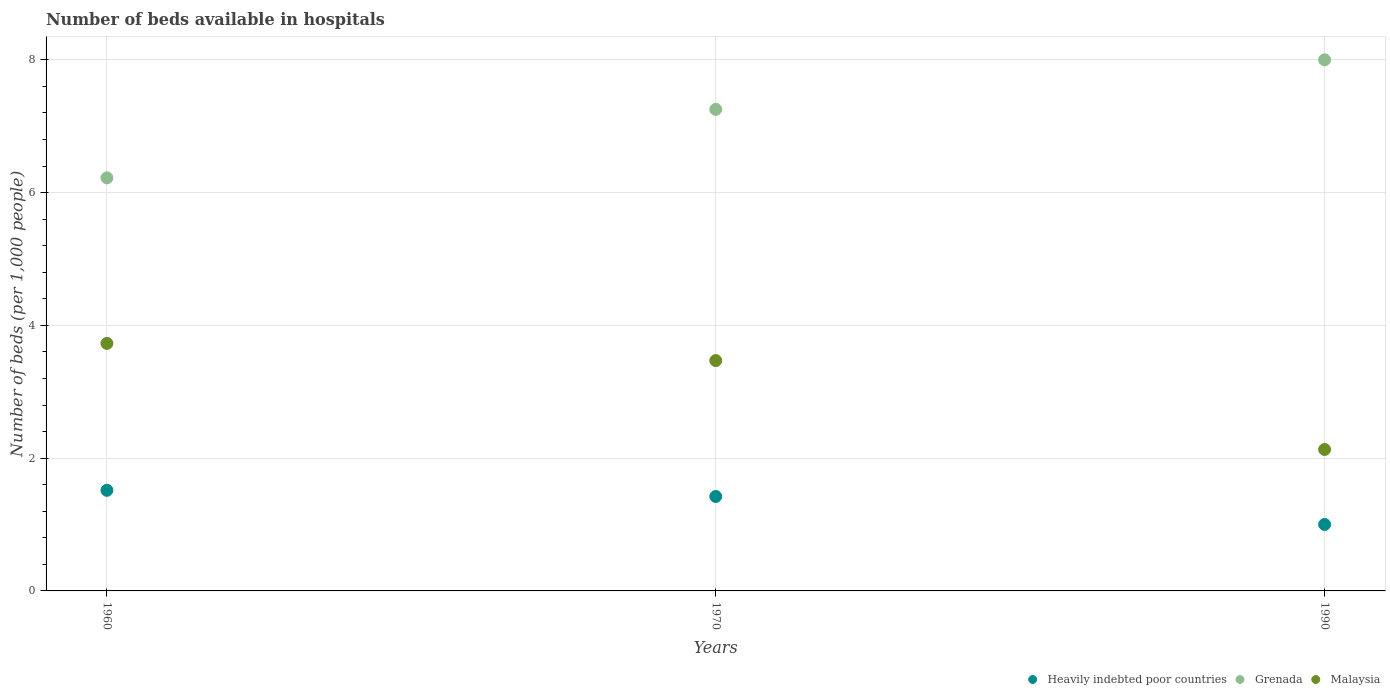How many different coloured dotlines are there?
Offer a terse response. 3. Is the number of dotlines equal to the number of legend labels?
Your response must be concise. Yes. What is the number of beds in the hospiatls of in Heavily indebted poor countries in 1960?
Make the answer very short. 1.52. Across all years, what is the maximum number of beds in the hospiatls of in Grenada?
Your answer should be compact. 8. Across all years, what is the minimum number of beds in the hospiatls of in Malaysia?
Your answer should be very brief. 2.13. In which year was the number of beds in the hospiatls of in Malaysia maximum?
Your answer should be very brief. 1960. In which year was the number of beds in the hospiatls of in Grenada minimum?
Keep it short and to the point. 1960. What is the total number of beds in the hospiatls of in Grenada in the graph?
Offer a terse response. 21.48. What is the difference between the number of beds in the hospiatls of in Grenada in 1970 and that in 1990?
Offer a terse response. -0.75. What is the difference between the number of beds in the hospiatls of in Malaysia in 1990 and the number of beds in the hospiatls of in Heavily indebted poor countries in 1970?
Offer a very short reply. 0.71. What is the average number of beds in the hospiatls of in Grenada per year?
Give a very brief answer. 7.16. In the year 1990, what is the difference between the number of beds in the hospiatls of in Heavily indebted poor countries and number of beds in the hospiatls of in Malaysia?
Your answer should be very brief. -1.13. What is the ratio of the number of beds in the hospiatls of in Grenada in 1960 to that in 1970?
Give a very brief answer. 0.86. Is the number of beds in the hospiatls of in Grenada in 1960 less than that in 1990?
Ensure brevity in your answer.  Yes. What is the difference between the highest and the second highest number of beds in the hospiatls of in Heavily indebted poor countries?
Provide a succinct answer. 0.09. What is the difference between the highest and the lowest number of beds in the hospiatls of in Heavily indebted poor countries?
Ensure brevity in your answer.  0.51. In how many years, is the number of beds in the hospiatls of in Malaysia greater than the average number of beds in the hospiatls of in Malaysia taken over all years?
Offer a terse response. 2. Is the sum of the number of beds in the hospiatls of in Malaysia in 1970 and 1990 greater than the maximum number of beds in the hospiatls of in Heavily indebted poor countries across all years?
Provide a succinct answer. Yes. Is it the case that in every year, the sum of the number of beds in the hospiatls of in Grenada and number of beds in the hospiatls of in Heavily indebted poor countries  is greater than the number of beds in the hospiatls of in Malaysia?
Provide a short and direct response. Yes. Is the number of beds in the hospiatls of in Grenada strictly greater than the number of beds in the hospiatls of in Heavily indebted poor countries over the years?
Offer a very short reply. Yes. How many dotlines are there?
Your answer should be very brief. 3. How many years are there in the graph?
Your answer should be very brief. 3. Are the values on the major ticks of Y-axis written in scientific E-notation?
Offer a very short reply. No. Does the graph contain any zero values?
Give a very brief answer. No. Where does the legend appear in the graph?
Give a very brief answer. Bottom right. How many legend labels are there?
Your answer should be very brief. 3. What is the title of the graph?
Ensure brevity in your answer.  Number of beds available in hospitals. What is the label or title of the Y-axis?
Your answer should be very brief. Number of beds (per 1,0 people). What is the Number of beds (per 1,000 people) of Heavily indebted poor countries in 1960?
Ensure brevity in your answer.  1.52. What is the Number of beds (per 1,000 people) of Grenada in 1960?
Provide a short and direct response. 6.22. What is the Number of beds (per 1,000 people) of Malaysia in 1960?
Give a very brief answer. 3.73. What is the Number of beds (per 1,000 people) of Heavily indebted poor countries in 1970?
Provide a succinct answer. 1.42. What is the Number of beds (per 1,000 people) in Grenada in 1970?
Your answer should be compact. 7.25. What is the Number of beds (per 1,000 people) in Malaysia in 1970?
Your answer should be compact. 3.47. What is the Number of beds (per 1,000 people) in Heavily indebted poor countries in 1990?
Offer a very short reply. 1. What is the Number of beds (per 1,000 people) of Grenada in 1990?
Your answer should be compact. 8. What is the Number of beds (per 1,000 people) in Malaysia in 1990?
Make the answer very short. 2.13. Across all years, what is the maximum Number of beds (per 1,000 people) in Heavily indebted poor countries?
Provide a succinct answer. 1.52. Across all years, what is the maximum Number of beds (per 1,000 people) of Grenada?
Make the answer very short. 8. Across all years, what is the maximum Number of beds (per 1,000 people) of Malaysia?
Offer a terse response. 3.73. Across all years, what is the minimum Number of beds (per 1,000 people) in Heavily indebted poor countries?
Offer a very short reply. 1. Across all years, what is the minimum Number of beds (per 1,000 people) in Grenada?
Provide a succinct answer. 6.22. Across all years, what is the minimum Number of beds (per 1,000 people) in Malaysia?
Provide a succinct answer. 2.13. What is the total Number of beds (per 1,000 people) of Heavily indebted poor countries in the graph?
Give a very brief answer. 3.94. What is the total Number of beds (per 1,000 people) in Grenada in the graph?
Offer a terse response. 21.48. What is the total Number of beds (per 1,000 people) in Malaysia in the graph?
Your response must be concise. 9.33. What is the difference between the Number of beds (per 1,000 people) of Heavily indebted poor countries in 1960 and that in 1970?
Ensure brevity in your answer.  0.09. What is the difference between the Number of beds (per 1,000 people) in Grenada in 1960 and that in 1970?
Offer a terse response. -1.03. What is the difference between the Number of beds (per 1,000 people) in Malaysia in 1960 and that in 1970?
Provide a succinct answer. 0.26. What is the difference between the Number of beds (per 1,000 people) of Heavily indebted poor countries in 1960 and that in 1990?
Keep it short and to the point. 0.51. What is the difference between the Number of beds (per 1,000 people) in Grenada in 1960 and that in 1990?
Make the answer very short. -1.78. What is the difference between the Number of beds (per 1,000 people) of Malaysia in 1960 and that in 1990?
Ensure brevity in your answer.  1.6. What is the difference between the Number of beds (per 1,000 people) in Heavily indebted poor countries in 1970 and that in 1990?
Ensure brevity in your answer.  0.42. What is the difference between the Number of beds (per 1,000 people) of Grenada in 1970 and that in 1990?
Provide a short and direct response. -0.75. What is the difference between the Number of beds (per 1,000 people) of Malaysia in 1970 and that in 1990?
Provide a short and direct response. 1.34. What is the difference between the Number of beds (per 1,000 people) of Heavily indebted poor countries in 1960 and the Number of beds (per 1,000 people) of Grenada in 1970?
Offer a very short reply. -5.74. What is the difference between the Number of beds (per 1,000 people) in Heavily indebted poor countries in 1960 and the Number of beds (per 1,000 people) in Malaysia in 1970?
Provide a succinct answer. -1.95. What is the difference between the Number of beds (per 1,000 people) in Grenada in 1960 and the Number of beds (per 1,000 people) in Malaysia in 1970?
Your answer should be compact. 2.75. What is the difference between the Number of beds (per 1,000 people) in Heavily indebted poor countries in 1960 and the Number of beds (per 1,000 people) in Grenada in 1990?
Your response must be concise. -6.48. What is the difference between the Number of beds (per 1,000 people) of Heavily indebted poor countries in 1960 and the Number of beds (per 1,000 people) of Malaysia in 1990?
Ensure brevity in your answer.  -0.61. What is the difference between the Number of beds (per 1,000 people) of Grenada in 1960 and the Number of beds (per 1,000 people) of Malaysia in 1990?
Offer a very short reply. 4.09. What is the difference between the Number of beds (per 1,000 people) in Heavily indebted poor countries in 1970 and the Number of beds (per 1,000 people) in Grenada in 1990?
Make the answer very short. -6.58. What is the difference between the Number of beds (per 1,000 people) of Heavily indebted poor countries in 1970 and the Number of beds (per 1,000 people) of Malaysia in 1990?
Offer a terse response. -0.71. What is the difference between the Number of beds (per 1,000 people) in Grenada in 1970 and the Number of beds (per 1,000 people) in Malaysia in 1990?
Offer a very short reply. 5.12. What is the average Number of beds (per 1,000 people) in Heavily indebted poor countries per year?
Your answer should be very brief. 1.31. What is the average Number of beds (per 1,000 people) in Grenada per year?
Your answer should be very brief. 7.16. What is the average Number of beds (per 1,000 people) of Malaysia per year?
Your response must be concise. 3.11. In the year 1960, what is the difference between the Number of beds (per 1,000 people) in Heavily indebted poor countries and Number of beds (per 1,000 people) in Grenada?
Give a very brief answer. -4.71. In the year 1960, what is the difference between the Number of beds (per 1,000 people) of Heavily indebted poor countries and Number of beds (per 1,000 people) of Malaysia?
Make the answer very short. -2.21. In the year 1960, what is the difference between the Number of beds (per 1,000 people) in Grenada and Number of beds (per 1,000 people) in Malaysia?
Your response must be concise. 2.49. In the year 1970, what is the difference between the Number of beds (per 1,000 people) of Heavily indebted poor countries and Number of beds (per 1,000 people) of Grenada?
Make the answer very short. -5.83. In the year 1970, what is the difference between the Number of beds (per 1,000 people) of Heavily indebted poor countries and Number of beds (per 1,000 people) of Malaysia?
Offer a very short reply. -2.05. In the year 1970, what is the difference between the Number of beds (per 1,000 people) of Grenada and Number of beds (per 1,000 people) of Malaysia?
Provide a succinct answer. 3.78. In the year 1990, what is the difference between the Number of beds (per 1,000 people) in Heavily indebted poor countries and Number of beds (per 1,000 people) in Grenada?
Give a very brief answer. -7. In the year 1990, what is the difference between the Number of beds (per 1,000 people) in Heavily indebted poor countries and Number of beds (per 1,000 people) in Malaysia?
Make the answer very short. -1.13. In the year 1990, what is the difference between the Number of beds (per 1,000 people) in Grenada and Number of beds (per 1,000 people) in Malaysia?
Provide a short and direct response. 5.87. What is the ratio of the Number of beds (per 1,000 people) in Heavily indebted poor countries in 1960 to that in 1970?
Your response must be concise. 1.07. What is the ratio of the Number of beds (per 1,000 people) of Grenada in 1960 to that in 1970?
Make the answer very short. 0.86. What is the ratio of the Number of beds (per 1,000 people) in Malaysia in 1960 to that in 1970?
Give a very brief answer. 1.07. What is the ratio of the Number of beds (per 1,000 people) in Heavily indebted poor countries in 1960 to that in 1990?
Your response must be concise. 1.51. What is the ratio of the Number of beds (per 1,000 people) in Grenada in 1960 to that in 1990?
Ensure brevity in your answer.  0.78. What is the ratio of the Number of beds (per 1,000 people) of Malaysia in 1960 to that in 1990?
Offer a terse response. 1.75. What is the ratio of the Number of beds (per 1,000 people) in Heavily indebted poor countries in 1970 to that in 1990?
Offer a terse response. 1.42. What is the ratio of the Number of beds (per 1,000 people) of Grenada in 1970 to that in 1990?
Keep it short and to the point. 0.91. What is the ratio of the Number of beds (per 1,000 people) of Malaysia in 1970 to that in 1990?
Keep it short and to the point. 1.63. What is the difference between the highest and the second highest Number of beds (per 1,000 people) in Heavily indebted poor countries?
Provide a succinct answer. 0.09. What is the difference between the highest and the second highest Number of beds (per 1,000 people) of Grenada?
Your response must be concise. 0.75. What is the difference between the highest and the second highest Number of beds (per 1,000 people) of Malaysia?
Your answer should be very brief. 0.26. What is the difference between the highest and the lowest Number of beds (per 1,000 people) in Heavily indebted poor countries?
Provide a short and direct response. 0.51. What is the difference between the highest and the lowest Number of beds (per 1,000 people) in Grenada?
Offer a very short reply. 1.78. What is the difference between the highest and the lowest Number of beds (per 1,000 people) of Malaysia?
Your response must be concise. 1.6. 